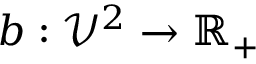Convert formula to latex. <formula><loc_0><loc_0><loc_500><loc_500>b \colon \mathcal { V } ^ { 2 } \to \mathbb { R } _ { + }</formula> 